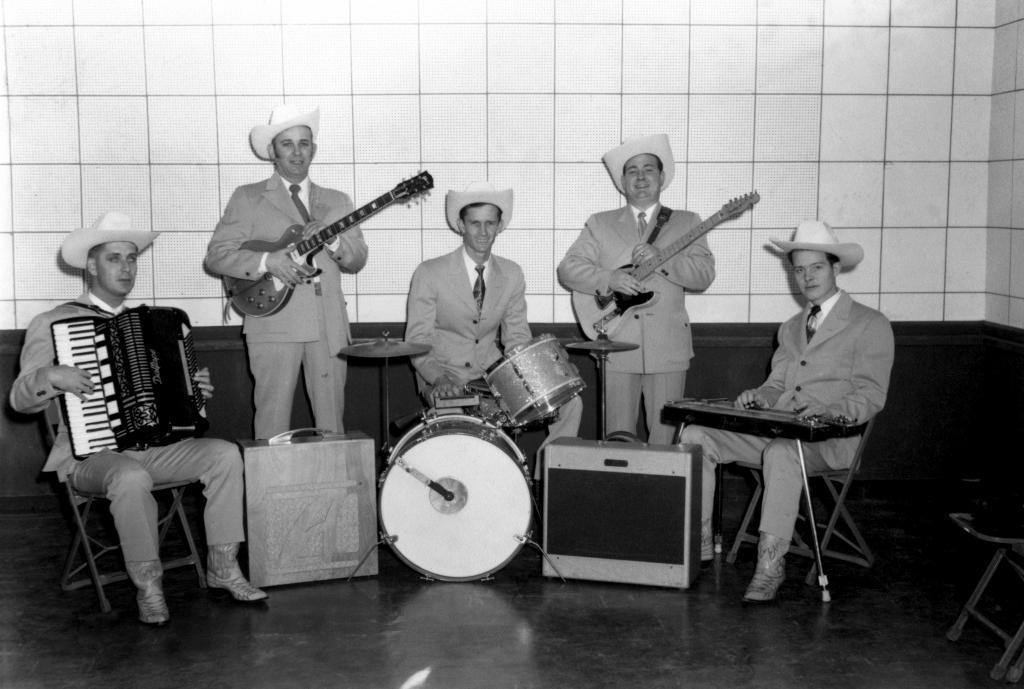In one or two sentences, can you explain what this image depicts? These five persons are holding musical instruments and wear hats,these two persons are standing and these three persons are sitting on the chairs. We can see musical instruments on the floor. On the background we can see wall. 